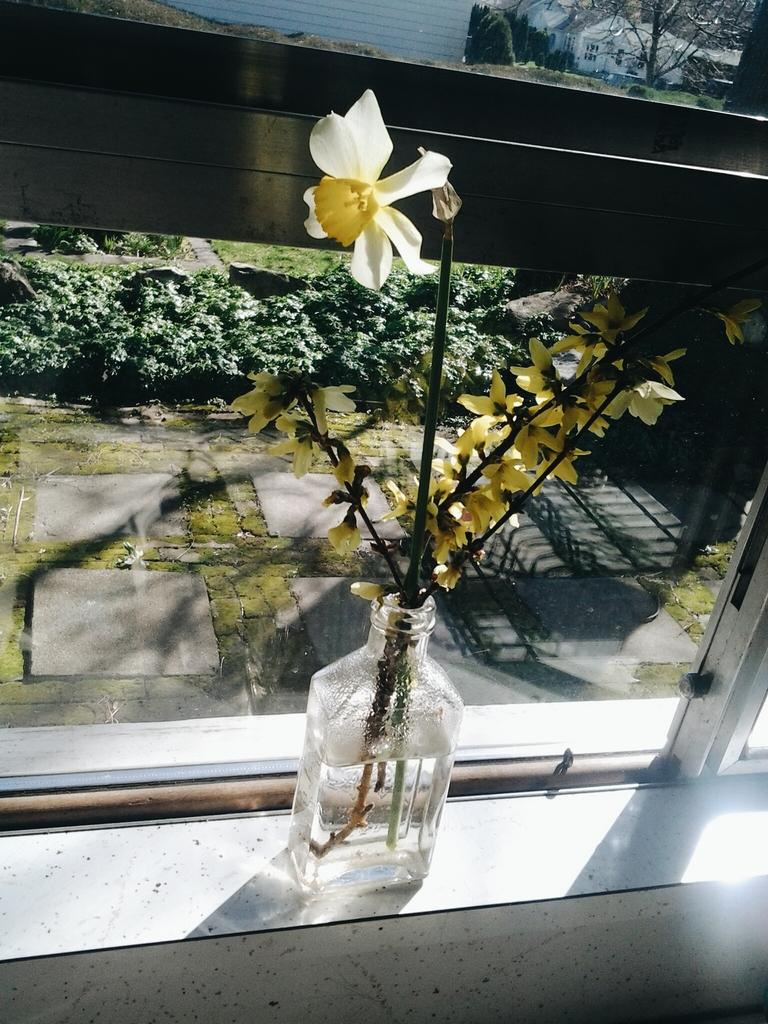What is inside the glass bottle in the image? There is a flower in a glass bottle in the image. Where is the flower located in relation to the window? The flower is in front of a window. What other plants can be seen in the image? There are plants at the bottom of the image. What type of building is visible in the image? There is a home visible in the image. Where is the home located in the image? The home is in the right side corner of the image. What is in front of the home? There is a tree in front of the home. How much money is hanging from the tree in the image? There is no money hanging from the tree in the image; it is a tree with no visible objects or currency. 